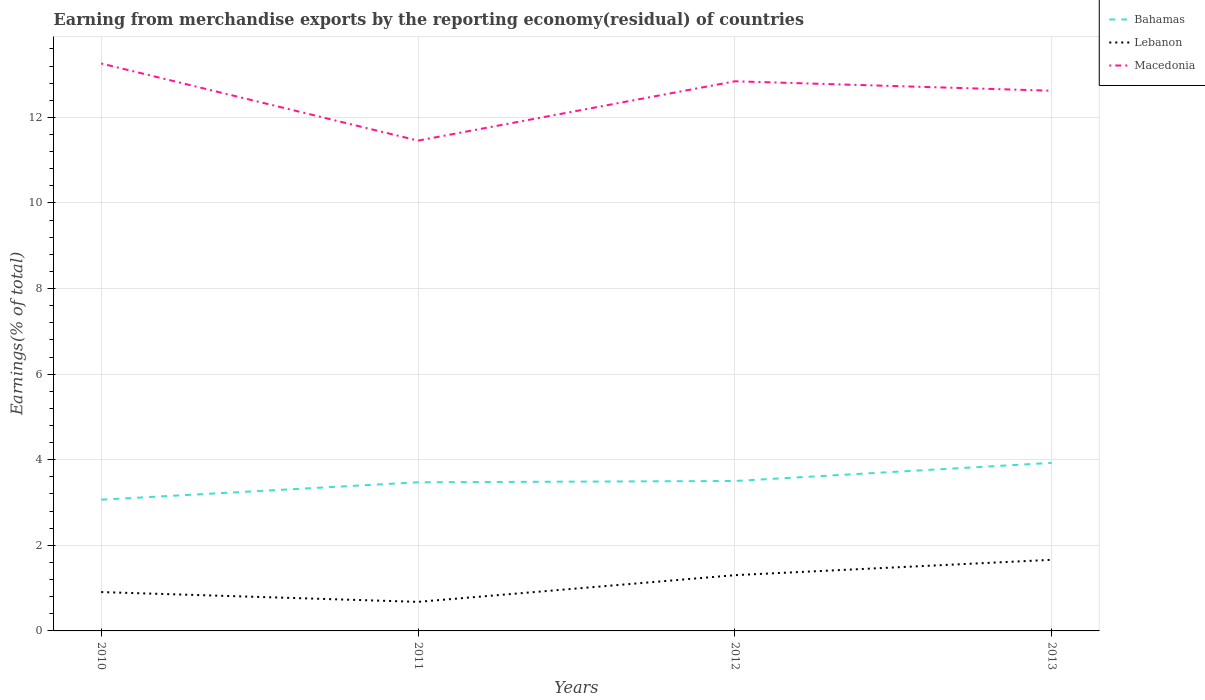How many different coloured lines are there?
Give a very brief answer. 3. Across all years, what is the maximum percentage of amount earned from merchandise exports in Bahamas?
Your answer should be very brief. 3.07. In which year was the percentage of amount earned from merchandise exports in Bahamas maximum?
Provide a short and direct response. 2010. What is the total percentage of amount earned from merchandise exports in Lebanon in the graph?
Your answer should be compact. -0.4. What is the difference between the highest and the second highest percentage of amount earned from merchandise exports in Bahamas?
Offer a terse response. 0.86. What is the difference between the highest and the lowest percentage of amount earned from merchandise exports in Bahamas?
Keep it short and to the point. 2. Is the percentage of amount earned from merchandise exports in Bahamas strictly greater than the percentage of amount earned from merchandise exports in Lebanon over the years?
Provide a short and direct response. No. How many lines are there?
Offer a terse response. 3. What is the difference between two consecutive major ticks on the Y-axis?
Provide a short and direct response. 2. Where does the legend appear in the graph?
Your response must be concise. Top right. How many legend labels are there?
Give a very brief answer. 3. How are the legend labels stacked?
Keep it short and to the point. Vertical. What is the title of the graph?
Ensure brevity in your answer.  Earning from merchandise exports by the reporting economy(residual) of countries. What is the label or title of the Y-axis?
Give a very brief answer. Earnings(% of total). What is the Earnings(% of total) of Bahamas in 2010?
Your response must be concise. 3.07. What is the Earnings(% of total) in Lebanon in 2010?
Your answer should be very brief. 0.91. What is the Earnings(% of total) of Macedonia in 2010?
Your answer should be very brief. 13.26. What is the Earnings(% of total) in Bahamas in 2011?
Provide a short and direct response. 3.47. What is the Earnings(% of total) of Lebanon in 2011?
Your answer should be very brief. 0.68. What is the Earnings(% of total) of Macedonia in 2011?
Keep it short and to the point. 11.46. What is the Earnings(% of total) in Bahamas in 2012?
Give a very brief answer. 3.5. What is the Earnings(% of total) in Lebanon in 2012?
Make the answer very short. 1.3. What is the Earnings(% of total) of Macedonia in 2012?
Ensure brevity in your answer.  12.84. What is the Earnings(% of total) in Bahamas in 2013?
Provide a succinct answer. 3.93. What is the Earnings(% of total) in Lebanon in 2013?
Make the answer very short. 1.66. What is the Earnings(% of total) in Macedonia in 2013?
Offer a very short reply. 12.62. Across all years, what is the maximum Earnings(% of total) in Bahamas?
Offer a very short reply. 3.93. Across all years, what is the maximum Earnings(% of total) in Lebanon?
Ensure brevity in your answer.  1.66. Across all years, what is the maximum Earnings(% of total) in Macedonia?
Ensure brevity in your answer.  13.26. Across all years, what is the minimum Earnings(% of total) in Bahamas?
Your answer should be very brief. 3.07. Across all years, what is the minimum Earnings(% of total) of Lebanon?
Offer a terse response. 0.68. Across all years, what is the minimum Earnings(% of total) of Macedonia?
Ensure brevity in your answer.  11.46. What is the total Earnings(% of total) of Bahamas in the graph?
Give a very brief answer. 13.97. What is the total Earnings(% of total) of Lebanon in the graph?
Your response must be concise. 4.55. What is the total Earnings(% of total) in Macedonia in the graph?
Make the answer very short. 50.18. What is the difference between the Earnings(% of total) in Bahamas in 2010 and that in 2011?
Ensure brevity in your answer.  -0.41. What is the difference between the Earnings(% of total) in Lebanon in 2010 and that in 2011?
Your answer should be very brief. 0.23. What is the difference between the Earnings(% of total) in Macedonia in 2010 and that in 2011?
Offer a terse response. 1.8. What is the difference between the Earnings(% of total) in Bahamas in 2010 and that in 2012?
Ensure brevity in your answer.  -0.44. What is the difference between the Earnings(% of total) of Lebanon in 2010 and that in 2012?
Provide a short and direct response. -0.4. What is the difference between the Earnings(% of total) in Macedonia in 2010 and that in 2012?
Keep it short and to the point. 0.42. What is the difference between the Earnings(% of total) of Bahamas in 2010 and that in 2013?
Your answer should be compact. -0.86. What is the difference between the Earnings(% of total) in Lebanon in 2010 and that in 2013?
Your response must be concise. -0.75. What is the difference between the Earnings(% of total) in Macedonia in 2010 and that in 2013?
Your answer should be very brief. 0.64. What is the difference between the Earnings(% of total) in Bahamas in 2011 and that in 2012?
Keep it short and to the point. -0.03. What is the difference between the Earnings(% of total) of Lebanon in 2011 and that in 2012?
Ensure brevity in your answer.  -0.62. What is the difference between the Earnings(% of total) in Macedonia in 2011 and that in 2012?
Keep it short and to the point. -1.39. What is the difference between the Earnings(% of total) of Bahamas in 2011 and that in 2013?
Offer a terse response. -0.45. What is the difference between the Earnings(% of total) in Lebanon in 2011 and that in 2013?
Make the answer very short. -0.98. What is the difference between the Earnings(% of total) in Macedonia in 2011 and that in 2013?
Provide a succinct answer. -1.17. What is the difference between the Earnings(% of total) in Bahamas in 2012 and that in 2013?
Ensure brevity in your answer.  -0.42. What is the difference between the Earnings(% of total) in Lebanon in 2012 and that in 2013?
Your answer should be very brief. -0.36. What is the difference between the Earnings(% of total) in Macedonia in 2012 and that in 2013?
Your answer should be compact. 0.22. What is the difference between the Earnings(% of total) of Bahamas in 2010 and the Earnings(% of total) of Lebanon in 2011?
Offer a very short reply. 2.39. What is the difference between the Earnings(% of total) of Bahamas in 2010 and the Earnings(% of total) of Macedonia in 2011?
Your answer should be very brief. -8.39. What is the difference between the Earnings(% of total) in Lebanon in 2010 and the Earnings(% of total) in Macedonia in 2011?
Give a very brief answer. -10.55. What is the difference between the Earnings(% of total) in Bahamas in 2010 and the Earnings(% of total) in Lebanon in 2012?
Provide a short and direct response. 1.76. What is the difference between the Earnings(% of total) of Bahamas in 2010 and the Earnings(% of total) of Macedonia in 2012?
Provide a short and direct response. -9.78. What is the difference between the Earnings(% of total) in Lebanon in 2010 and the Earnings(% of total) in Macedonia in 2012?
Your answer should be very brief. -11.94. What is the difference between the Earnings(% of total) in Bahamas in 2010 and the Earnings(% of total) in Lebanon in 2013?
Provide a succinct answer. 1.4. What is the difference between the Earnings(% of total) in Bahamas in 2010 and the Earnings(% of total) in Macedonia in 2013?
Your answer should be very brief. -9.56. What is the difference between the Earnings(% of total) in Lebanon in 2010 and the Earnings(% of total) in Macedonia in 2013?
Ensure brevity in your answer.  -11.71. What is the difference between the Earnings(% of total) of Bahamas in 2011 and the Earnings(% of total) of Lebanon in 2012?
Your answer should be compact. 2.17. What is the difference between the Earnings(% of total) in Bahamas in 2011 and the Earnings(% of total) in Macedonia in 2012?
Your answer should be compact. -9.37. What is the difference between the Earnings(% of total) in Lebanon in 2011 and the Earnings(% of total) in Macedonia in 2012?
Provide a succinct answer. -12.16. What is the difference between the Earnings(% of total) of Bahamas in 2011 and the Earnings(% of total) of Lebanon in 2013?
Provide a short and direct response. 1.81. What is the difference between the Earnings(% of total) in Bahamas in 2011 and the Earnings(% of total) in Macedonia in 2013?
Give a very brief answer. -9.15. What is the difference between the Earnings(% of total) of Lebanon in 2011 and the Earnings(% of total) of Macedonia in 2013?
Give a very brief answer. -11.94. What is the difference between the Earnings(% of total) in Bahamas in 2012 and the Earnings(% of total) in Lebanon in 2013?
Offer a terse response. 1.84. What is the difference between the Earnings(% of total) in Bahamas in 2012 and the Earnings(% of total) in Macedonia in 2013?
Your response must be concise. -9.12. What is the difference between the Earnings(% of total) in Lebanon in 2012 and the Earnings(% of total) in Macedonia in 2013?
Your answer should be very brief. -11.32. What is the average Earnings(% of total) of Bahamas per year?
Ensure brevity in your answer.  3.49. What is the average Earnings(% of total) of Lebanon per year?
Offer a very short reply. 1.14. What is the average Earnings(% of total) of Macedonia per year?
Keep it short and to the point. 12.55. In the year 2010, what is the difference between the Earnings(% of total) of Bahamas and Earnings(% of total) of Lebanon?
Your answer should be compact. 2.16. In the year 2010, what is the difference between the Earnings(% of total) of Bahamas and Earnings(% of total) of Macedonia?
Your answer should be very brief. -10.19. In the year 2010, what is the difference between the Earnings(% of total) in Lebanon and Earnings(% of total) in Macedonia?
Your response must be concise. -12.35. In the year 2011, what is the difference between the Earnings(% of total) in Bahamas and Earnings(% of total) in Lebanon?
Ensure brevity in your answer.  2.79. In the year 2011, what is the difference between the Earnings(% of total) in Bahamas and Earnings(% of total) in Macedonia?
Your answer should be compact. -7.98. In the year 2011, what is the difference between the Earnings(% of total) of Lebanon and Earnings(% of total) of Macedonia?
Provide a short and direct response. -10.78. In the year 2012, what is the difference between the Earnings(% of total) of Bahamas and Earnings(% of total) of Lebanon?
Your answer should be compact. 2.2. In the year 2012, what is the difference between the Earnings(% of total) in Bahamas and Earnings(% of total) in Macedonia?
Your answer should be very brief. -9.34. In the year 2012, what is the difference between the Earnings(% of total) in Lebanon and Earnings(% of total) in Macedonia?
Make the answer very short. -11.54. In the year 2013, what is the difference between the Earnings(% of total) in Bahamas and Earnings(% of total) in Lebanon?
Your answer should be very brief. 2.27. In the year 2013, what is the difference between the Earnings(% of total) of Bahamas and Earnings(% of total) of Macedonia?
Make the answer very short. -8.7. In the year 2013, what is the difference between the Earnings(% of total) of Lebanon and Earnings(% of total) of Macedonia?
Your answer should be compact. -10.96. What is the ratio of the Earnings(% of total) of Bahamas in 2010 to that in 2011?
Offer a very short reply. 0.88. What is the ratio of the Earnings(% of total) of Lebanon in 2010 to that in 2011?
Provide a short and direct response. 1.34. What is the ratio of the Earnings(% of total) in Macedonia in 2010 to that in 2011?
Offer a terse response. 1.16. What is the ratio of the Earnings(% of total) in Bahamas in 2010 to that in 2012?
Give a very brief answer. 0.88. What is the ratio of the Earnings(% of total) of Lebanon in 2010 to that in 2012?
Your response must be concise. 0.7. What is the ratio of the Earnings(% of total) in Macedonia in 2010 to that in 2012?
Your answer should be very brief. 1.03. What is the ratio of the Earnings(% of total) in Bahamas in 2010 to that in 2013?
Your answer should be very brief. 0.78. What is the ratio of the Earnings(% of total) in Lebanon in 2010 to that in 2013?
Your response must be concise. 0.55. What is the ratio of the Earnings(% of total) in Macedonia in 2010 to that in 2013?
Provide a succinct answer. 1.05. What is the ratio of the Earnings(% of total) in Lebanon in 2011 to that in 2012?
Offer a terse response. 0.52. What is the ratio of the Earnings(% of total) of Macedonia in 2011 to that in 2012?
Offer a terse response. 0.89. What is the ratio of the Earnings(% of total) of Bahamas in 2011 to that in 2013?
Ensure brevity in your answer.  0.88. What is the ratio of the Earnings(% of total) in Lebanon in 2011 to that in 2013?
Provide a short and direct response. 0.41. What is the ratio of the Earnings(% of total) in Macedonia in 2011 to that in 2013?
Your answer should be compact. 0.91. What is the ratio of the Earnings(% of total) in Bahamas in 2012 to that in 2013?
Ensure brevity in your answer.  0.89. What is the ratio of the Earnings(% of total) of Lebanon in 2012 to that in 2013?
Your answer should be compact. 0.78. What is the ratio of the Earnings(% of total) of Macedonia in 2012 to that in 2013?
Provide a succinct answer. 1.02. What is the difference between the highest and the second highest Earnings(% of total) in Bahamas?
Provide a short and direct response. 0.42. What is the difference between the highest and the second highest Earnings(% of total) in Lebanon?
Provide a short and direct response. 0.36. What is the difference between the highest and the second highest Earnings(% of total) in Macedonia?
Your response must be concise. 0.42. What is the difference between the highest and the lowest Earnings(% of total) of Bahamas?
Provide a succinct answer. 0.86. What is the difference between the highest and the lowest Earnings(% of total) of Lebanon?
Offer a very short reply. 0.98. What is the difference between the highest and the lowest Earnings(% of total) of Macedonia?
Your response must be concise. 1.8. 